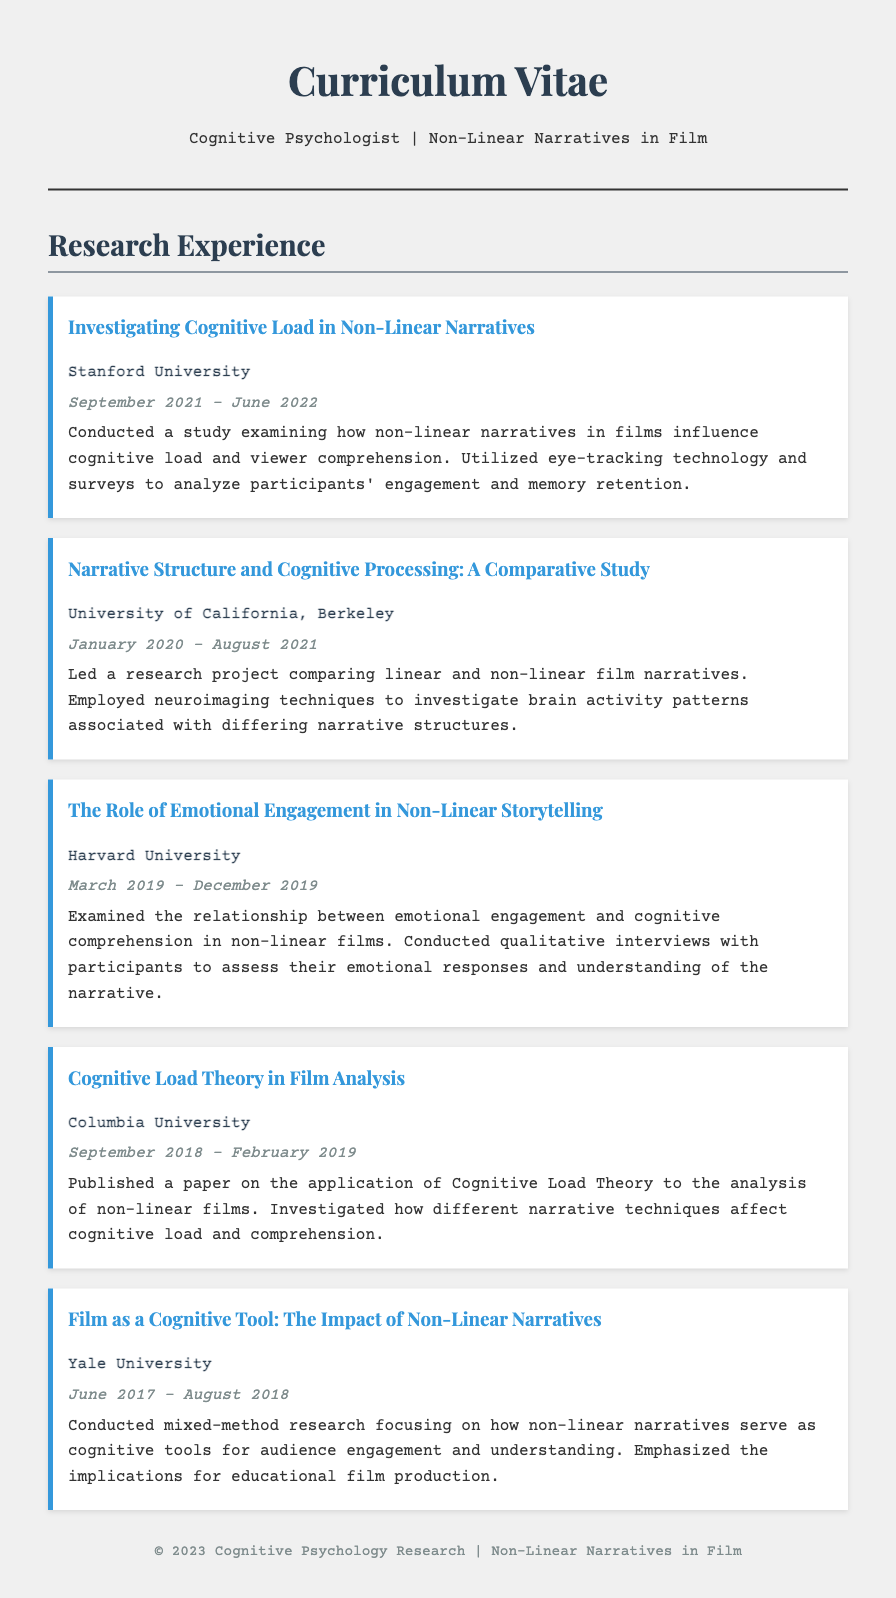what is the title of the first research experience listed? The title of the first research experience is mentioned in the document as "Investigating Cognitive Load in Non-Linear Narratives."
Answer: Investigating Cognitive Load in Non-Linear Narratives who conducted a study on the role of emotional engagement in non-linear storytelling? The document indicates that this study was conducted at Harvard University.
Answer: Harvard University what was the duration of the study at Columbia University? The duration of the study is specified in the document as September 2018 to February 2019.
Answer: September 2018 - February 2019 which university is associated with the study on narrative structure and cognitive processing? The document states that the study was done at the University of California, Berkeley.
Answer: University of California, Berkeley how many research projects are listed in the research experience section? The total count of research projects mentioned in the document can be derived from the listings.
Answer: Five what technology was used in the study on cognitive load? The document notes that eye-tracking technology was utilized in the study.
Answer: Eye-tracking technology which cognitive theory was applied to the analysis of non-linear films? The analysis referenced in the document used Cognitive Load Theory.
Answer: Cognitive Load Theory what is the focus of the research conducted at Yale University? The document highlights that the research focused on non-linear narratives as cognitive tools for engagement.
Answer: Non-linear narratives as cognitive tools what year did the research on emotional engagement begin? The year this research started is specified as 2019 in the document.
Answer: 2019 